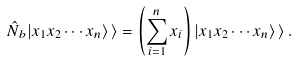<formula> <loc_0><loc_0><loc_500><loc_500>\hat { N } _ { b } | x _ { 1 } x _ { 2 } \cdots x _ { n } \rangle \, \rangle = \left ( \sum _ { i = 1 } ^ { n } x _ { i } \right ) | x _ { 1 } x _ { 2 } \cdots x _ { n } \rangle \, \rangle \, .</formula> 